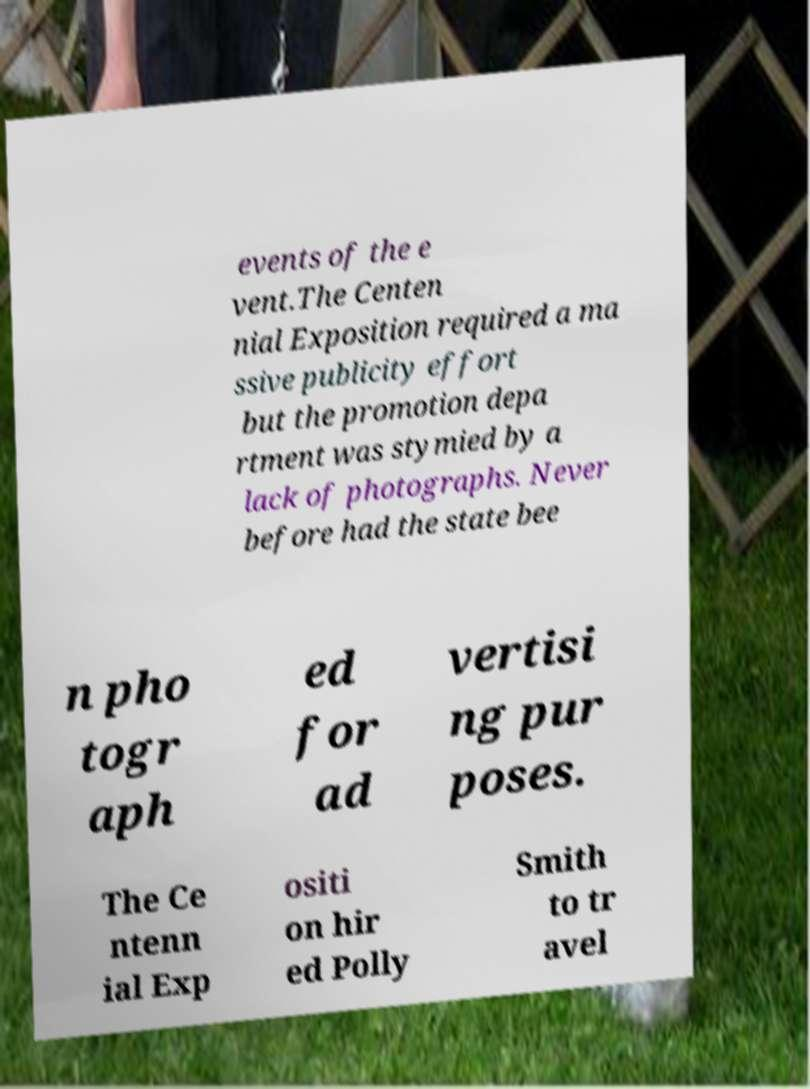For documentation purposes, I need the text within this image transcribed. Could you provide that? events of the e vent.The Centen nial Exposition required a ma ssive publicity effort but the promotion depa rtment was stymied by a lack of photographs. Never before had the state bee n pho togr aph ed for ad vertisi ng pur poses. The Ce ntenn ial Exp ositi on hir ed Polly Smith to tr avel 